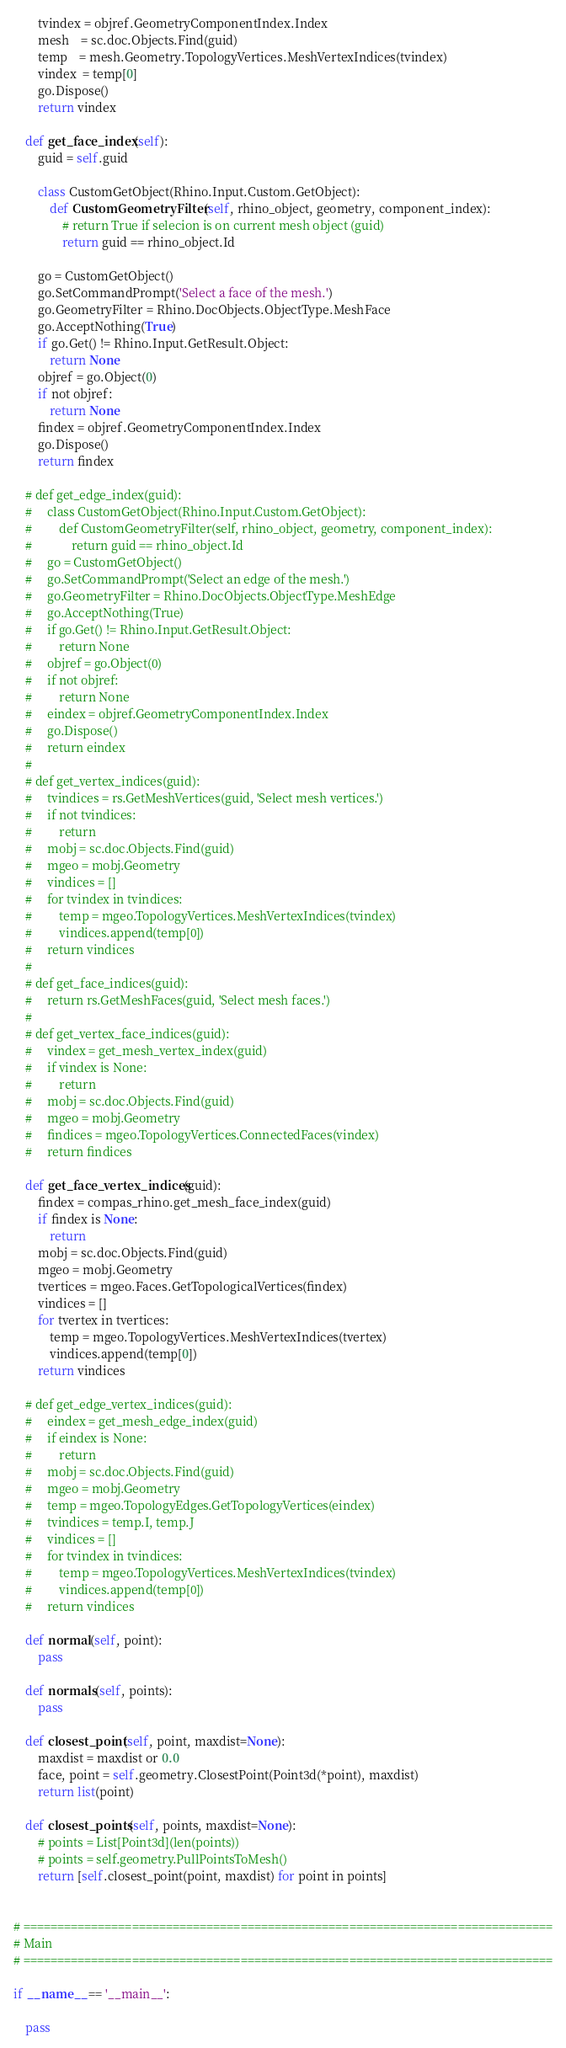<code> <loc_0><loc_0><loc_500><loc_500><_Python_>        tvindex = objref.GeometryComponentIndex.Index
        mesh    = sc.doc.Objects.Find(guid)
        temp    = mesh.Geometry.TopologyVertices.MeshVertexIndices(tvindex)
        vindex  = temp[0]
        go.Dispose()
        return vindex

    def get_face_index(self):
        guid = self.guid

        class CustomGetObject(Rhino.Input.Custom.GetObject):
            def CustomGeometryFilter(self, rhino_object, geometry, component_index):
                # return True if selecion is on current mesh object (guid)
                return guid == rhino_object.Id

        go = CustomGetObject()
        go.SetCommandPrompt('Select a face of the mesh.')
        go.GeometryFilter = Rhino.DocObjects.ObjectType.MeshFace
        go.AcceptNothing(True)
        if go.Get() != Rhino.Input.GetResult.Object:
            return None
        objref = go.Object(0)
        if not objref:
            return None
        findex = objref.GeometryComponentIndex.Index
        go.Dispose()
        return findex

    # def get_edge_index(guid):
    #     class CustomGetObject(Rhino.Input.Custom.GetObject):
    #         def CustomGeometryFilter(self, rhino_object, geometry, component_index):
    #             return guid == rhino_object.Id
    #     go = CustomGetObject()
    #     go.SetCommandPrompt('Select an edge of the mesh.')
    #     go.GeometryFilter = Rhino.DocObjects.ObjectType.MeshEdge
    #     go.AcceptNothing(True)
    #     if go.Get() != Rhino.Input.GetResult.Object:
    #         return None
    #     objref = go.Object(0)
    #     if not objref:
    #         return None
    #     eindex = objref.GeometryComponentIndex.Index
    #     go.Dispose()
    #     return eindex
    #
    # def get_vertex_indices(guid):
    #     tvindices = rs.GetMeshVertices(guid, 'Select mesh vertices.')
    #     if not tvindices:
    #         return
    #     mobj = sc.doc.Objects.Find(guid)
    #     mgeo = mobj.Geometry
    #     vindices = []
    #     for tvindex in tvindices:
    #         temp = mgeo.TopologyVertices.MeshVertexIndices(tvindex)
    #         vindices.append(temp[0])
    #     return vindices
    #
    # def get_face_indices(guid):
    #     return rs.GetMeshFaces(guid, 'Select mesh faces.')
    #
    # def get_vertex_face_indices(guid):
    #     vindex = get_mesh_vertex_index(guid)
    #     if vindex is None:
    #         return
    #     mobj = sc.doc.Objects.Find(guid)
    #     mgeo = mobj.Geometry
    #     findices = mgeo.TopologyVertices.ConnectedFaces(vindex)
    #     return findices

    def get_face_vertex_indices(guid):
        findex = compas_rhino.get_mesh_face_index(guid)
        if findex is None:
            return
        mobj = sc.doc.Objects.Find(guid)
        mgeo = mobj.Geometry
        tvertices = mgeo.Faces.GetTopologicalVertices(findex)
        vindices = []
        for tvertex in tvertices:
            temp = mgeo.TopologyVertices.MeshVertexIndices(tvertex)
            vindices.append(temp[0])
        return vindices

    # def get_edge_vertex_indices(guid):
    #     eindex = get_mesh_edge_index(guid)
    #     if eindex is None:
    #         return
    #     mobj = sc.doc.Objects.Find(guid)
    #     mgeo = mobj.Geometry
    #     temp = mgeo.TopologyEdges.GetTopologyVertices(eindex)
    #     tvindices = temp.I, temp.J
    #     vindices = []
    #     for tvindex in tvindices:
    #         temp = mgeo.TopologyVertices.MeshVertexIndices(tvindex)
    #         vindices.append(temp[0])
    #     return vindices

    def normal(self, point):
        pass

    def normals(self, points):
        pass

    def closest_point(self, point, maxdist=None):
        maxdist = maxdist or 0.0
        face, point = self.geometry.ClosestPoint(Point3d(*point), maxdist)
        return list(point)

    def closest_points(self, points, maxdist=None):
        # points = List[Point3d](len(points))
        # points = self.geometry.PullPointsToMesh()
        return [self.closest_point(point, maxdist) for point in points]


# ==============================================================================
# Main
# ==============================================================================

if __name__ == '__main__':

    pass
</code> 